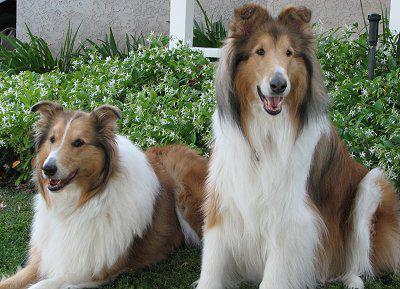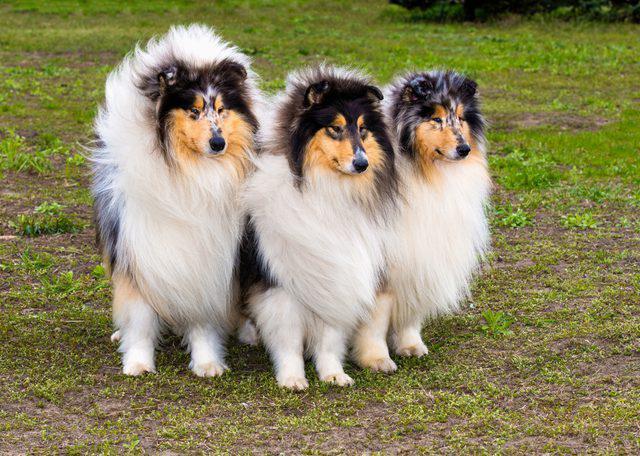The first image is the image on the left, the second image is the image on the right. For the images displayed, is the sentence "There are five collies in total." factually correct? Answer yes or no. Yes. The first image is the image on the left, the second image is the image on the right. Given the left and right images, does the statement "One image contains three collie dogs, and the other contains two." hold true? Answer yes or no. Yes. 